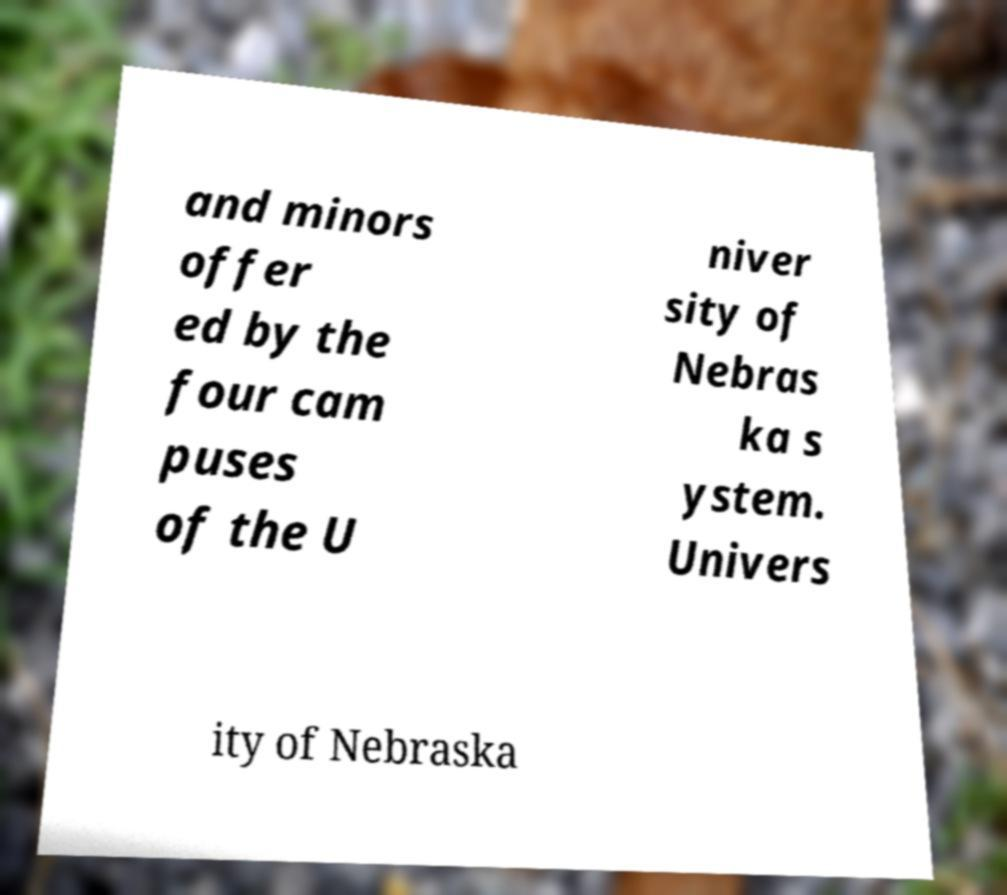There's text embedded in this image that I need extracted. Can you transcribe it verbatim? and minors offer ed by the four cam puses of the U niver sity of Nebras ka s ystem. Univers ity of Nebraska 